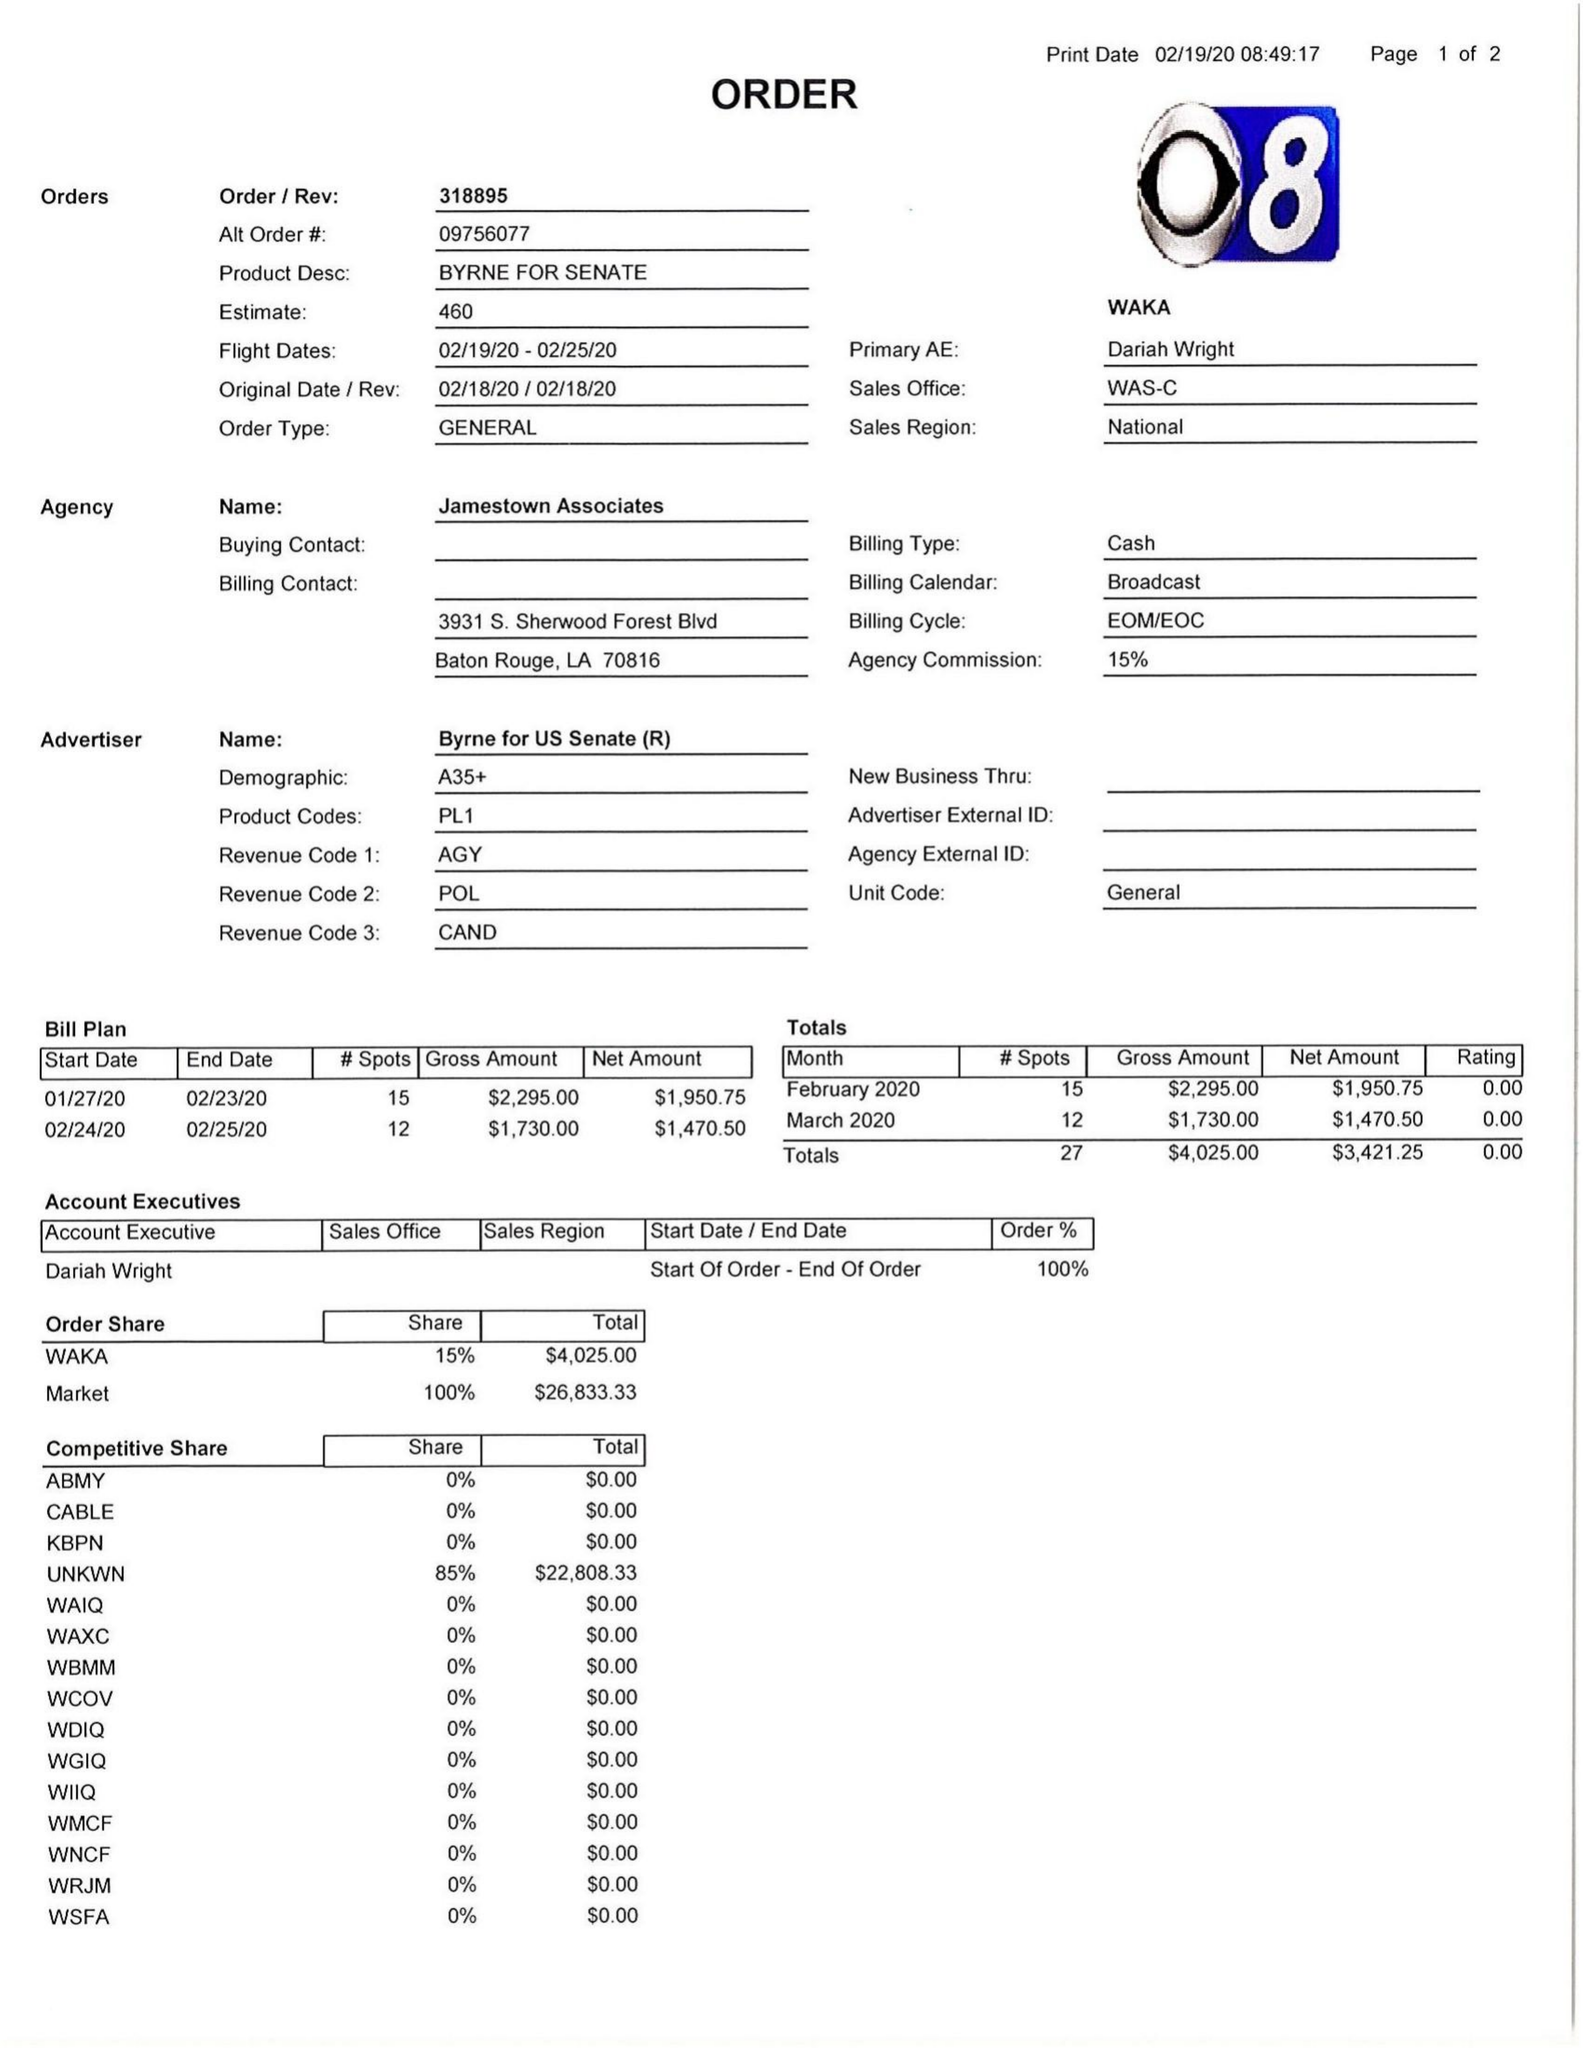What is the value for the advertiser?
Answer the question using a single word or phrase. BYRNE FOR US SENATE 